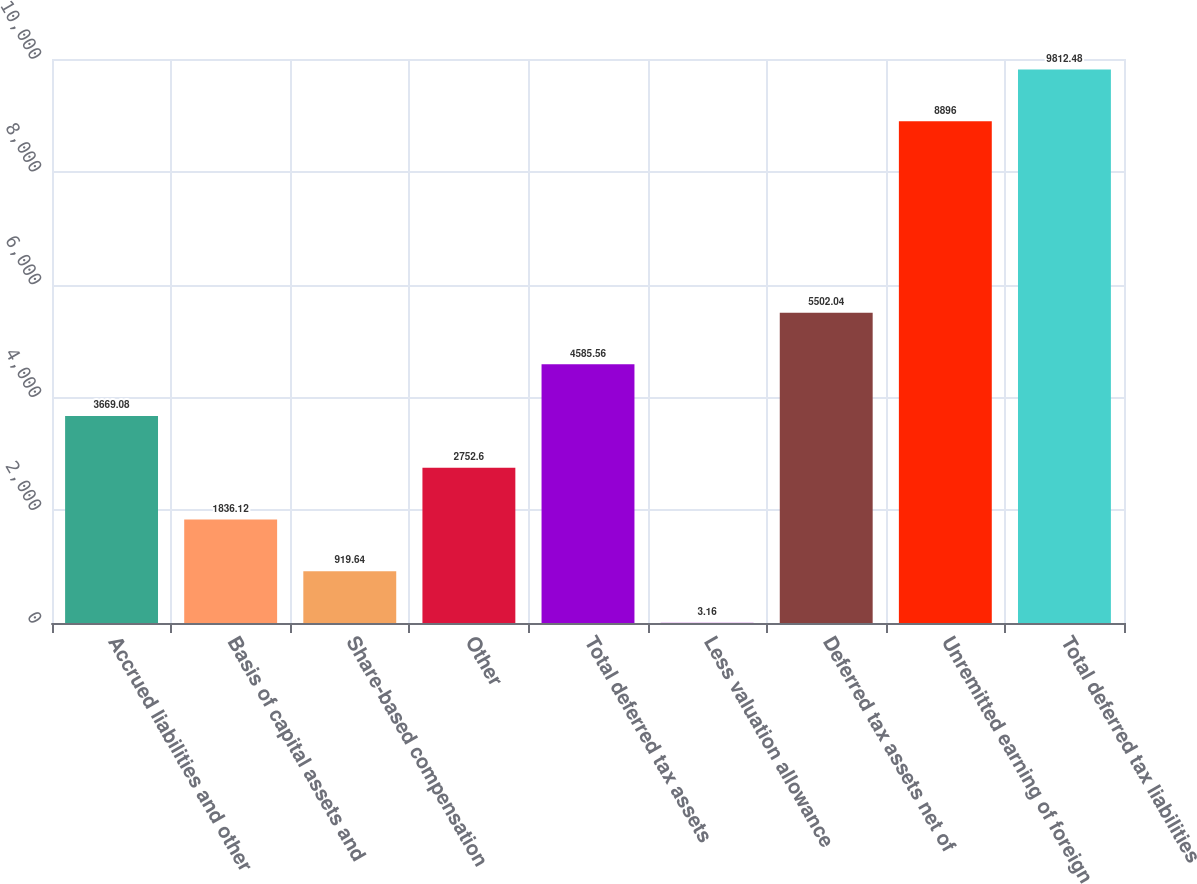<chart> <loc_0><loc_0><loc_500><loc_500><bar_chart><fcel>Accrued liabilities and other<fcel>Basis of capital assets and<fcel>Share-based compensation<fcel>Other<fcel>Total deferred tax assets<fcel>Less valuation allowance<fcel>Deferred tax assets net of<fcel>Unremitted earning of foreign<fcel>Total deferred tax liabilities<nl><fcel>3669.08<fcel>1836.12<fcel>919.64<fcel>2752.6<fcel>4585.56<fcel>3.16<fcel>5502.04<fcel>8896<fcel>9812.48<nl></chart> 